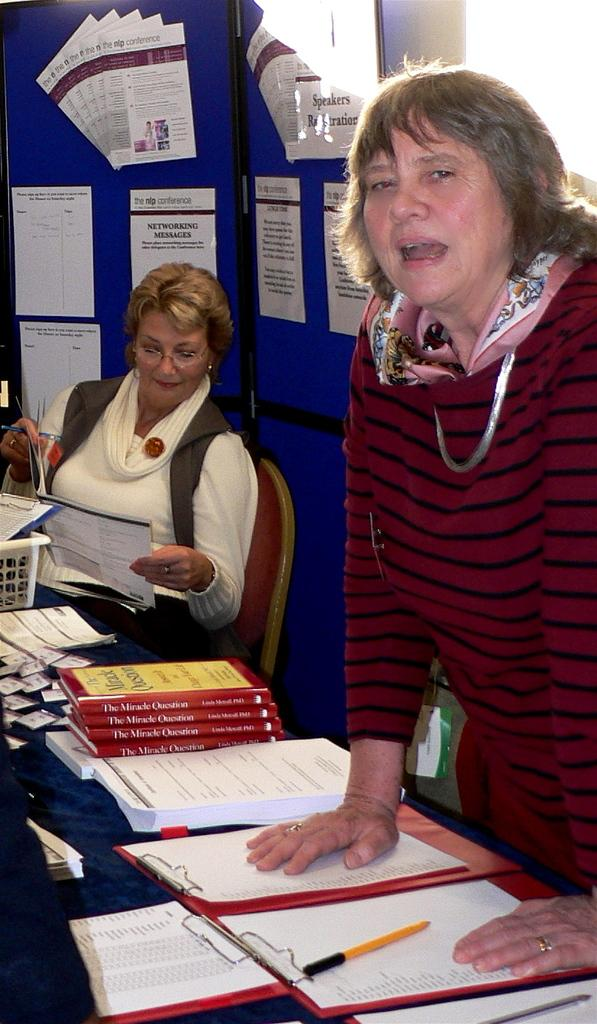<image>
Offer a succinct explanation of the picture presented. At a table where two women are working there are several copies of "The Miracle Question." 